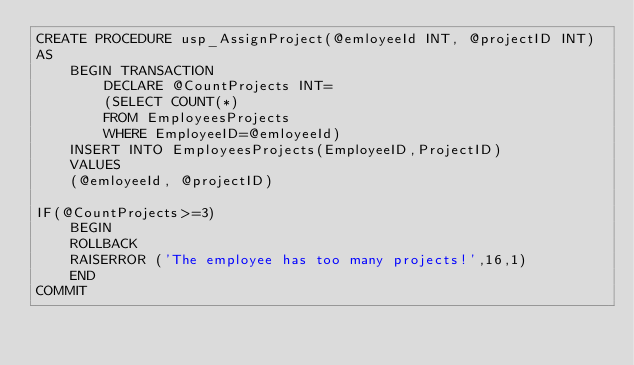Convert code to text. <code><loc_0><loc_0><loc_500><loc_500><_SQL_>CREATE PROCEDURE usp_AssignProject(@emloyeeId INT, @projectID INT) 
AS
	BEGIN TRANSACTION
		DECLARE @CountProjects INT=
		(SELECT COUNT(*)
		FROM EmployeesProjects
		WHERE EmployeeID=@emloyeeId)
	INSERT INTO EmployeesProjects(EmployeeID,ProjectID)
	VALUES
	(@emloyeeId, @projectID)

IF(@CountProjects>=3)
	BEGIN
	ROLLBACK
	RAISERROR ('The employee has too many projects!',16,1)
	END
COMMIT</code> 